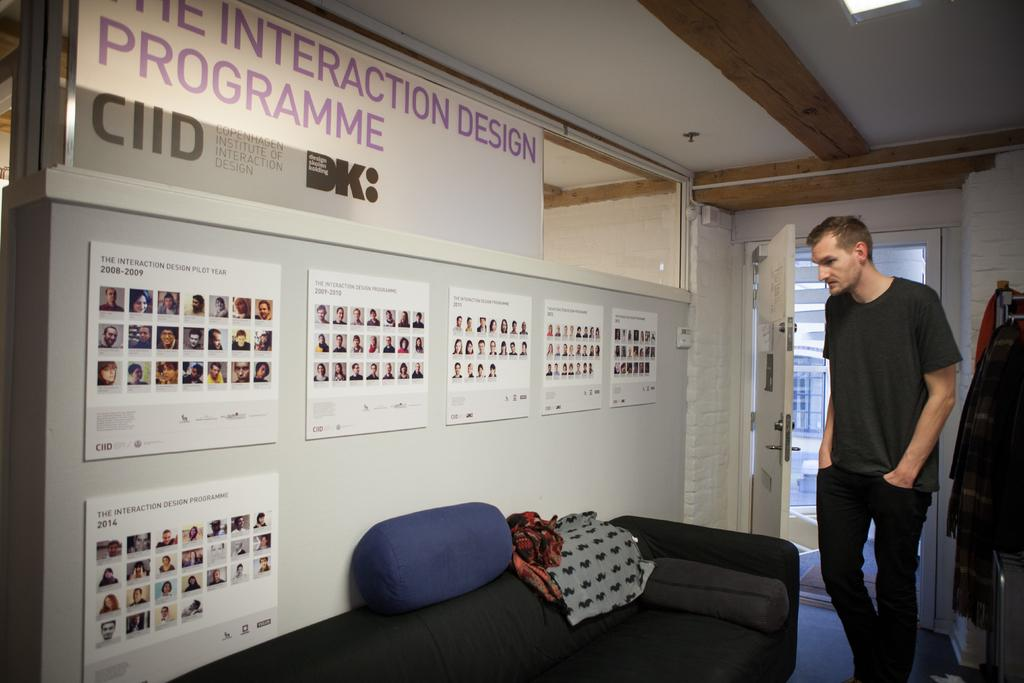What is the main subject in the image? There is a man standing in the image. What type of furniture is present in the image? There is a sofa with pillows in the image. What decorations can be seen on the wall? There are posters on the wall in the image. What architectural feature is present in the image? There is a door in the image. What items are related to clothing in the image? There are clothes in the image. What can be seen in the background of the image? There is a window visible in the background of the image. What type of island can be seen in the image? There is no island present in the image. How many cherries are on the sofa in the image? There are no cherries present in the image. 